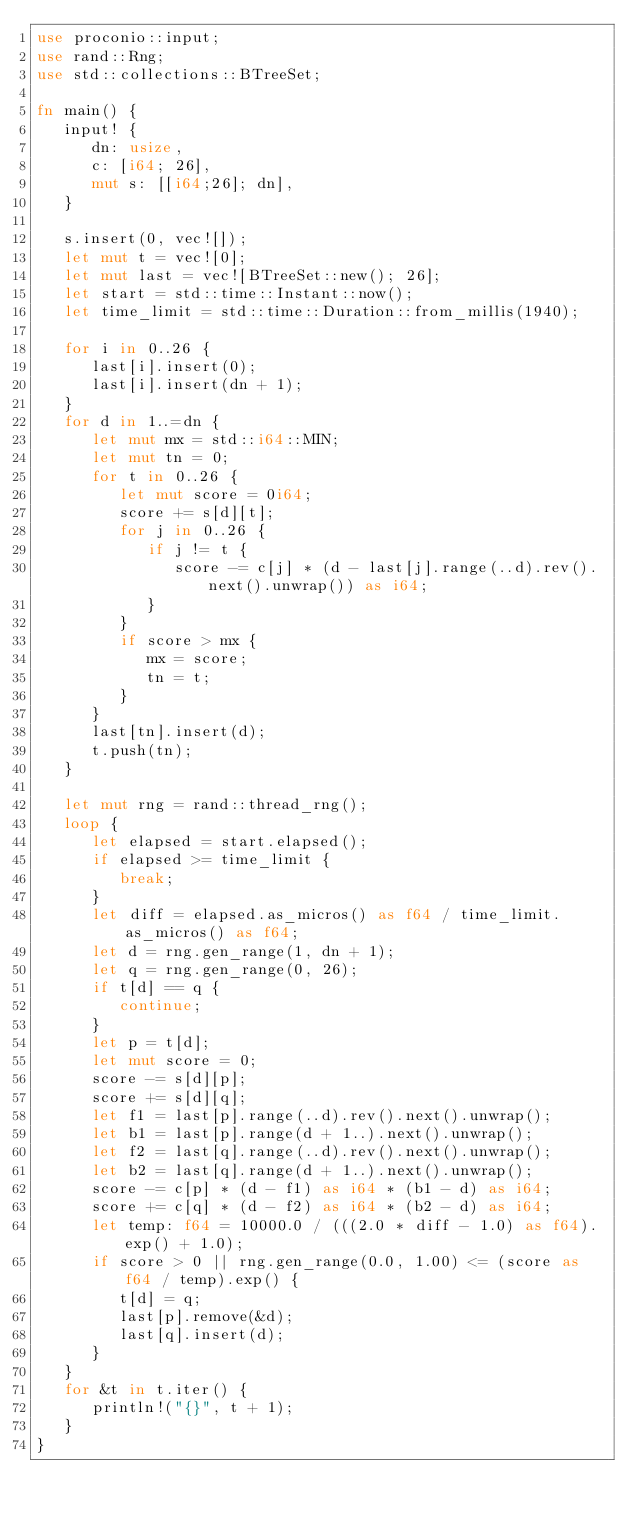Convert code to text. <code><loc_0><loc_0><loc_500><loc_500><_Rust_>use proconio::input;
use rand::Rng;
use std::collections::BTreeSet;

fn main() {
   input! {
      dn: usize,
      c: [i64; 26],
      mut s: [[i64;26]; dn],
   }

   s.insert(0, vec![]);
   let mut t = vec![0];
   let mut last = vec![BTreeSet::new(); 26];
   let start = std::time::Instant::now();
   let time_limit = std::time::Duration::from_millis(1940);

   for i in 0..26 {
      last[i].insert(0);
      last[i].insert(dn + 1);
   }
   for d in 1..=dn {
      let mut mx = std::i64::MIN;
      let mut tn = 0;
      for t in 0..26 {
         let mut score = 0i64;
         score += s[d][t];
         for j in 0..26 {
            if j != t {
               score -= c[j] * (d - last[j].range(..d).rev().next().unwrap()) as i64;
            }
         }
         if score > mx {
            mx = score;
            tn = t;
         }
      }
      last[tn].insert(d);
      t.push(tn);
   }

   let mut rng = rand::thread_rng();
   loop {
      let elapsed = start.elapsed();
      if elapsed >= time_limit {
         break;
      }
      let diff = elapsed.as_micros() as f64 / time_limit.as_micros() as f64;
      let d = rng.gen_range(1, dn + 1);
      let q = rng.gen_range(0, 26);
      if t[d] == q {
         continue;
      }
      let p = t[d];
      let mut score = 0;
      score -= s[d][p];
      score += s[d][q];
      let f1 = last[p].range(..d).rev().next().unwrap();
      let b1 = last[p].range(d + 1..).next().unwrap();
      let f2 = last[q].range(..d).rev().next().unwrap();
      let b2 = last[q].range(d + 1..).next().unwrap();
      score -= c[p] * (d - f1) as i64 * (b1 - d) as i64;
      score += c[q] * (d - f2) as i64 * (b2 - d) as i64;
      let temp: f64 = 10000.0 / (((2.0 * diff - 1.0) as f64).exp() + 1.0);
      if score > 0 || rng.gen_range(0.0, 1.00) <= (score as f64 / temp).exp() {
         t[d] = q;
         last[p].remove(&d);
         last[q].insert(d);
      }
   }
   for &t in t.iter() {
      println!("{}", t + 1);
   }
}
</code> 